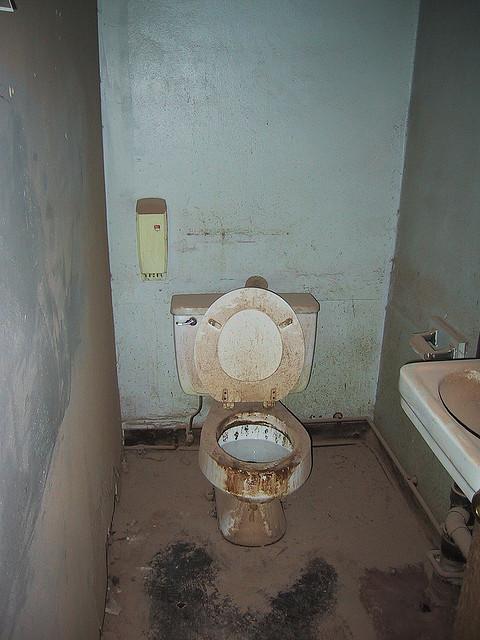Is there anyone in the bathroom?
Keep it brief. No. How many toilets are there?
Answer briefly. 1. Is the floor tiled?
Short answer required. No. What color is the basket?
Be succinct. Brown. How can you tell the toilet hasn't been used in a long time?
Concise answer only. Dirty. Is this a clean bathroom?
Keep it brief. No. What color is the toilet?
Give a very brief answer. Brown. 